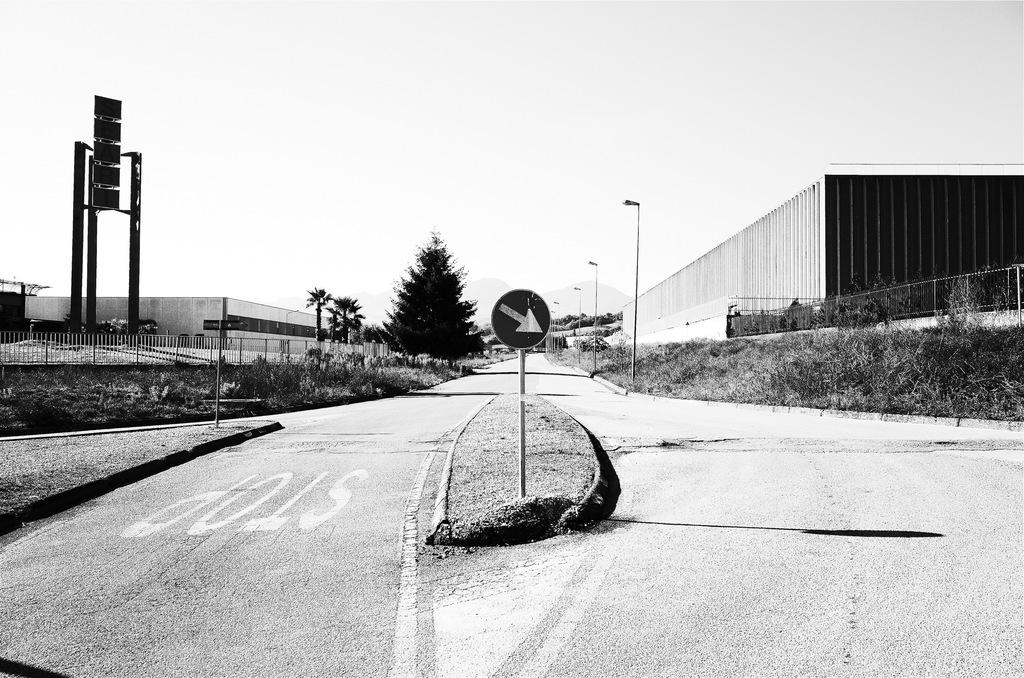What is the main object in the foreground of the image? There is a sign board in the image. What can be seen in the background of the image? There are trees, light poles, buildings, and the sky visible in the background of the image. What is the color scheme of the image? The image is in black and white. Can you see a hole in the sign board in the image? There is no hole visible in the sign board in the image. What phase of the moon is visible in the image? The image is in black and white and does not depict the moon, so it is not possible to determine the phase of the moon. 